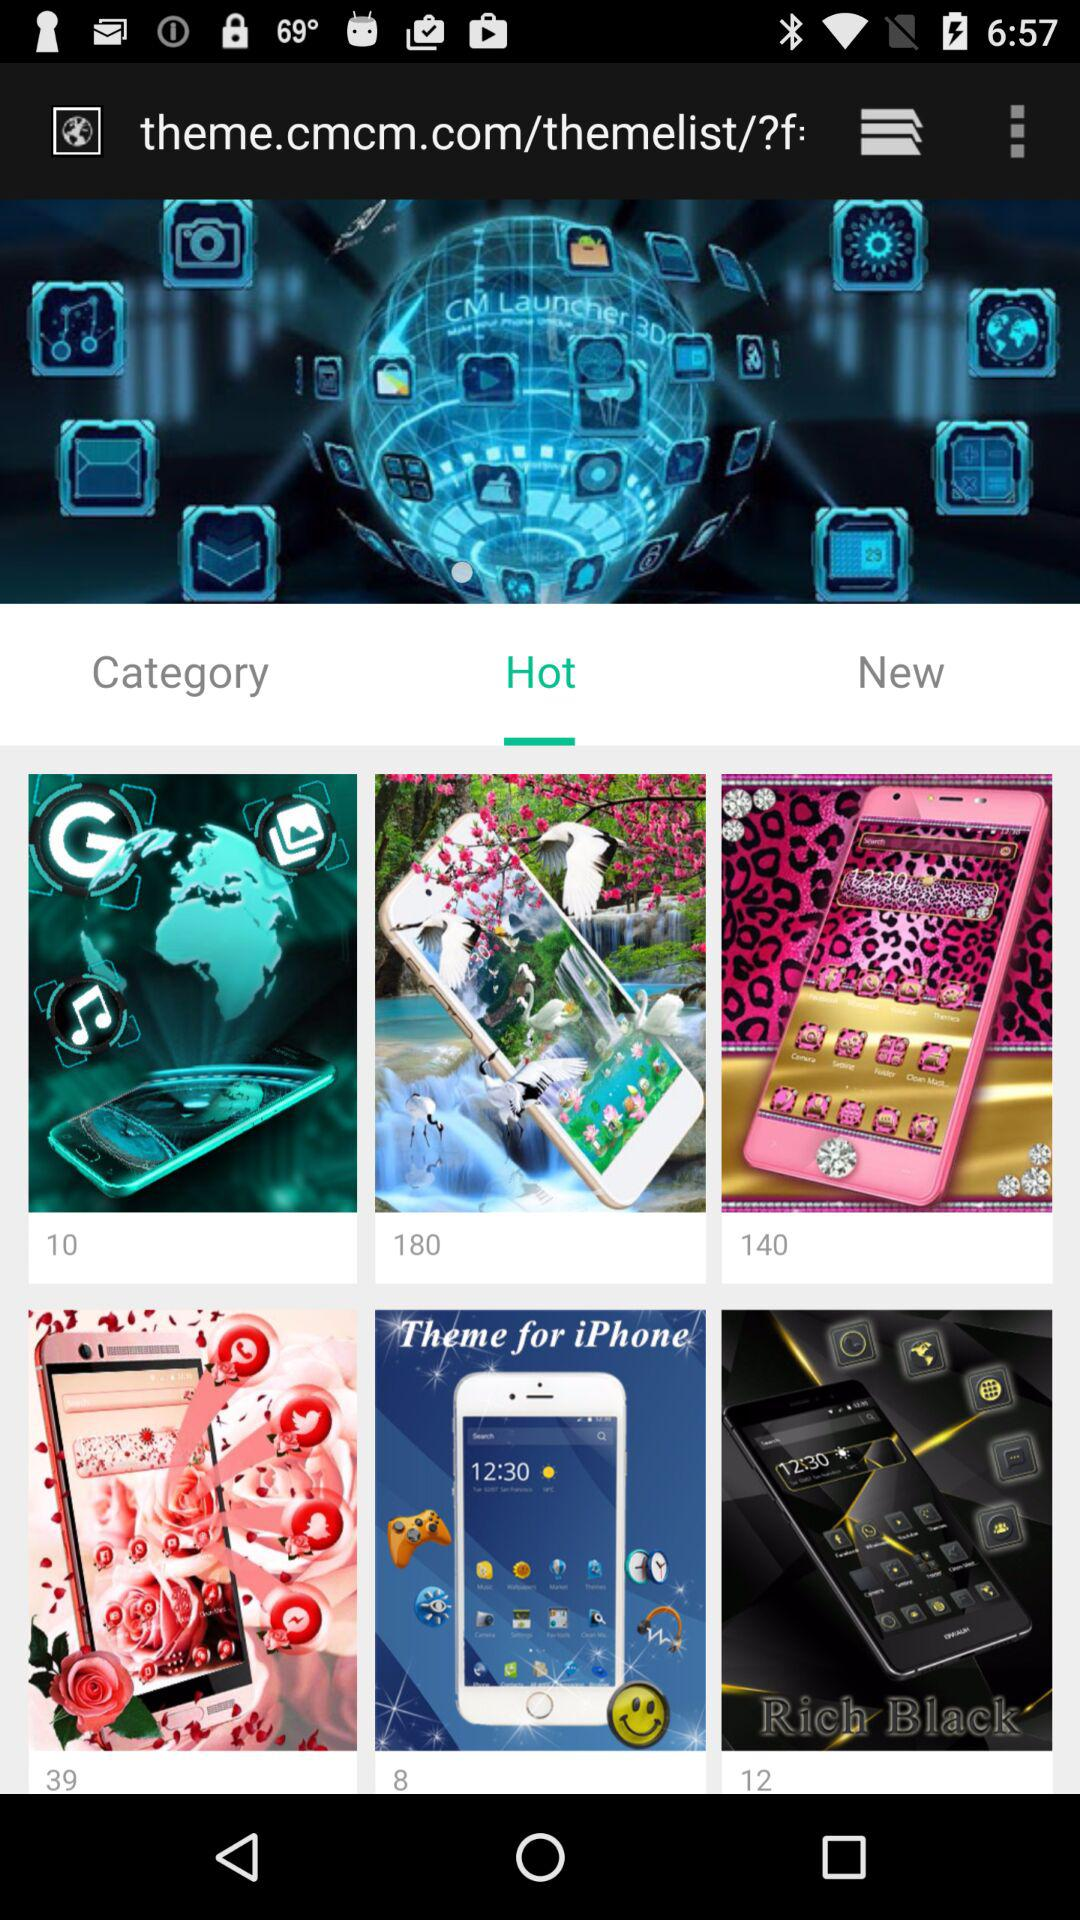Which tab is selected? The selected tab is "Hot". 